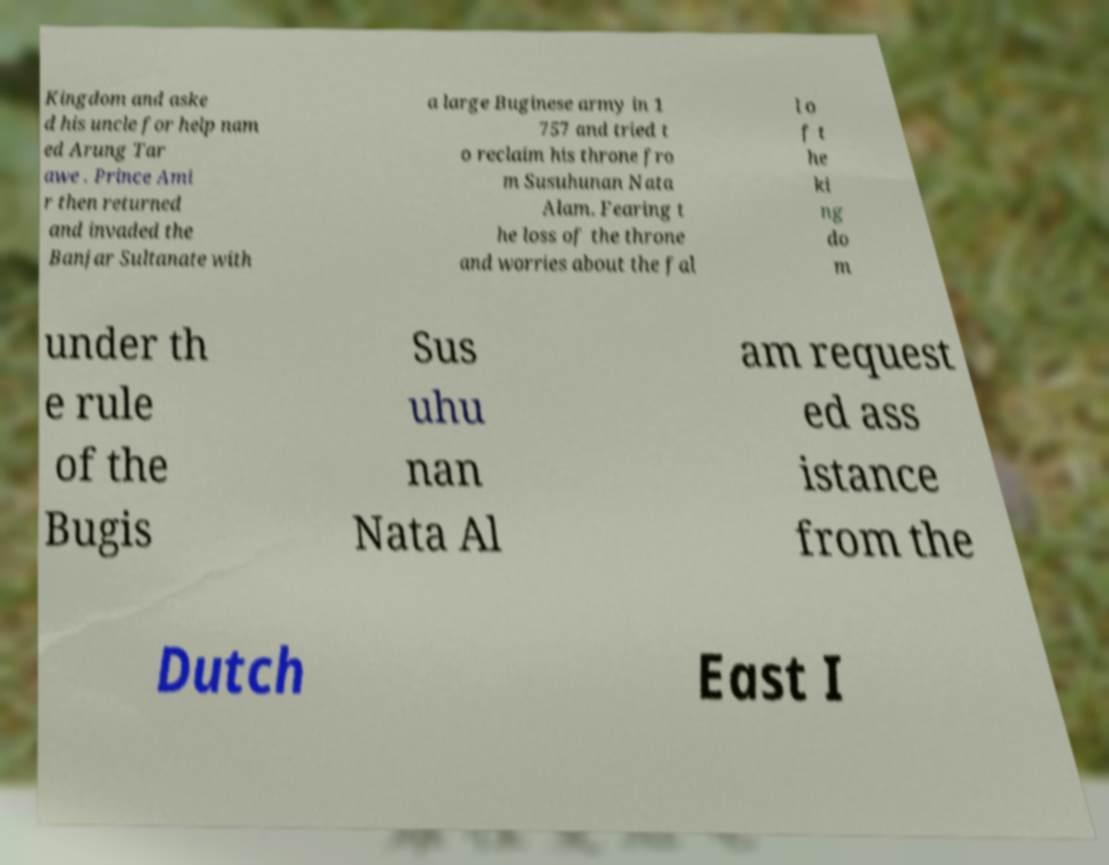For documentation purposes, I need the text within this image transcribed. Could you provide that? Kingdom and aske d his uncle for help nam ed Arung Tar awe . Prince Ami r then returned and invaded the Banjar Sultanate with a large Buginese army in 1 757 and tried t o reclaim his throne fro m Susuhunan Nata Alam. Fearing t he loss of the throne and worries about the fal l o f t he ki ng do m under th e rule of the Bugis Sus uhu nan Nata Al am request ed ass istance from the Dutch East I 